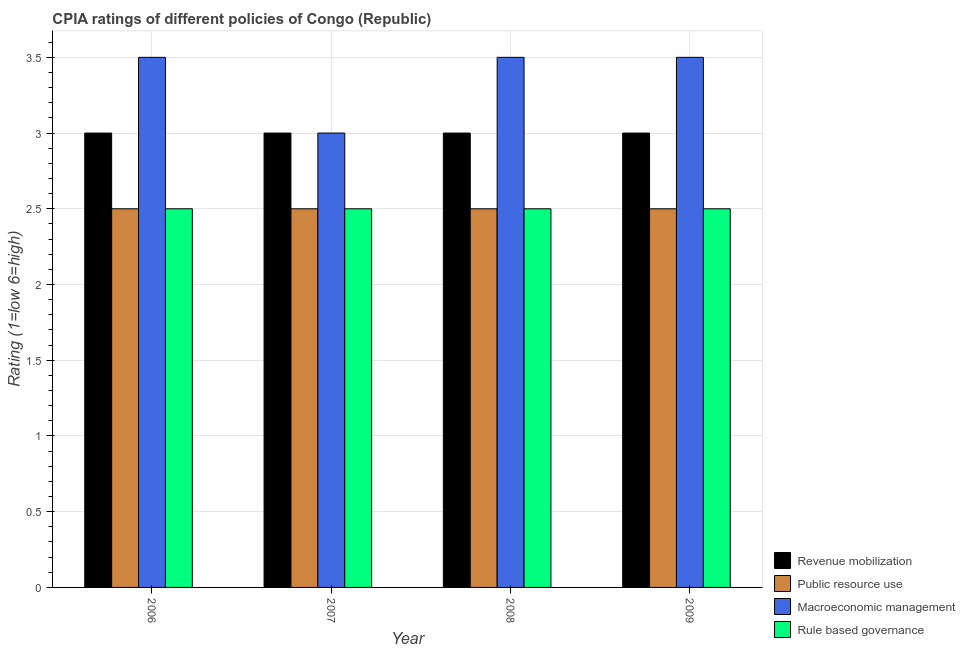How many groups of bars are there?
Provide a succinct answer. 4. Are the number of bars per tick equal to the number of legend labels?
Provide a succinct answer. Yes. Are the number of bars on each tick of the X-axis equal?
Keep it short and to the point. Yes. What is the label of the 3rd group of bars from the left?
Keep it short and to the point. 2008. What is the cpia rating of rule based governance in 2008?
Your response must be concise. 2.5. Across all years, what is the minimum cpia rating of rule based governance?
Your answer should be very brief. 2.5. In which year was the cpia rating of public resource use maximum?
Your answer should be very brief. 2006. What is the total cpia rating of public resource use in the graph?
Your answer should be very brief. 10. In the year 2009, what is the difference between the cpia rating of revenue mobilization and cpia rating of public resource use?
Keep it short and to the point. 0. Is the cpia rating of macroeconomic management in 2008 less than that in 2009?
Make the answer very short. No. What is the difference between the highest and the second highest cpia rating of revenue mobilization?
Ensure brevity in your answer.  0. In how many years, is the cpia rating of revenue mobilization greater than the average cpia rating of revenue mobilization taken over all years?
Ensure brevity in your answer.  0. Is the sum of the cpia rating of macroeconomic management in 2008 and 2009 greater than the maximum cpia rating of public resource use across all years?
Ensure brevity in your answer.  Yes. Is it the case that in every year, the sum of the cpia rating of rule based governance and cpia rating of revenue mobilization is greater than the sum of cpia rating of public resource use and cpia rating of macroeconomic management?
Offer a very short reply. No. What does the 2nd bar from the left in 2008 represents?
Your answer should be very brief. Public resource use. What does the 3rd bar from the right in 2006 represents?
Provide a short and direct response. Public resource use. Is it the case that in every year, the sum of the cpia rating of revenue mobilization and cpia rating of public resource use is greater than the cpia rating of macroeconomic management?
Give a very brief answer. Yes. How many years are there in the graph?
Provide a short and direct response. 4. Are the values on the major ticks of Y-axis written in scientific E-notation?
Your response must be concise. No. How are the legend labels stacked?
Your response must be concise. Vertical. What is the title of the graph?
Ensure brevity in your answer.  CPIA ratings of different policies of Congo (Republic). Does "First 20% of population" appear as one of the legend labels in the graph?
Give a very brief answer. No. What is the label or title of the Y-axis?
Make the answer very short. Rating (1=low 6=high). What is the Rating (1=low 6=high) in Revenue mobilization in 2006?
Give a very brief answer. 3. What is the Rating (1=low 6=high) in Public resource use in 2006?
Your answer should be compact. 2.5. What is the Rating (1=low 6=high) of Rule based governance in 2006?
Keep it short and to the point. 2.5. What is the Rating (1=low 6=high) of Revenue mobilization in 2007?
Ensure brevity in your answer.  3. What is the Rating (1=low 6=high) in Revenue mobilization in 2009?
Keep it short and to the point. 3. Across all years, what is the maximum Rating (1=low 6=high) in Revenue mobilization?
Your answer should be compact. 3. Across all years, what is the maximum Rating (1=low 6=high) in Public resource use?
Provide a succinct answer. 2.5. Across all years, what is the maximum Rating (1=low 6=high) of Macroeconomic management?
Your answer should be very brief. 3.5. Across all years, what is the maximum Rating (1=low 6=high) of Rule based governance?
Your response must be concise. 2.5. What is the total Rating (1=low 6=high) of Revenue mobilization in the graph?
Ensure brevity in your answer.  12. What is the total Rating (1=low 6=high) in Macroeconomic management in the graph?
Keep it short and to the point. 13.5. What is the difference between the Rating (1=low 6=high) in Revenue mobilization in 2006 and that in 2007?
Keep it short and to the point. 0. What is the difference between the Rating (1=low 6=high) in Public resource use in 2006 and that in 2007?
Keep it short and to the point. 0. What is the difference between the Rating (1=low 6=high) of Macroeconomic management in 2006 and that in 2007?
Give a very brief answer. 0.5. What is the difference between the Rating (1=low 6=high) in Revenue mobilization in 2006 and that in 2008?
Your answer should be very brief. 0. What is the difference between the Rating (1=low 6=high) of Public resource use in 2006 and that in 2008?
Give a very brief answer. 0. What is the difference between the Rating (1=low 6=high) of Macroeconomic management in 2006 and that in 2008?
Ensure brevity in your answer.  0. What is the difference between the Rating (1=low 6=high) in Public resource use in 2006 and that in 2009?
Your answer should be very brief. 0. What is the difference between the Rating (1=low 6=high) in Rule based governance in 2006 and that in 2009?
Keep it short and to the point. 0. What is the difference between the Rating (1=low 6=high) of Rule based governance in 2007 and that in 2008?
Give a very brief answer. 0. What is the difference between the Rating (1=low 6=high) of Revenue mobilization in 2007 and that in 2009?
Make the answer very short. 0. What is the difference between the Rating (1=low 6=high) in Public resource use in 2007 and that in 2009?
Provide a short and direct response. 0. What is the difference between the Rating (1=low 6=high) of Rule based governance in 2007 and that in 2009?
Make the answer very short. 0. What is the difference between the Rating (1=low 6=high) of Rule based governance in 2008 and that in 2009?
Your answer should be very brief. 0. What is the difference between the Rating (1=low 6=high) of Revenue mobilization in 2006 and the Rating (1=low 6=high) of Macroeconomic management in 2007?
Your answer should be compact. 0. What is the difference between the Rating (1=low 6=high) in Revenue mobilization in 2006 and the Rating (1=low 6=high) in Rule based governance in 2007?
Your answer should be compact. 0.5. What is the difference between the Rating (1=low 6=high) of Public resource use in 2006 and the Rating (1=low 6=high) of Macroeconomic management in 2007?
Your answer should be compact. -0.5. What is the difference between the Rating (1=low 6=high) in Revenue mobilization in 2006 and the Rating (1=low 6=high) in Public resource use in 2009?
Provide a succinct answer. 0.5. What is the difference between the Rating (1=low 6=high) of Revenue mobilization in 2006 and the Rating (1=low 6=high) of Macroeconomic management in 2009?
Provide a succinct answer. -0.5. What is the difference between the Rating (1=low 6=high) in Revenue mobilization in 2006 and the Rating (1=low 6=high) in Rule based governance in 2009?
Your response must be concise. 0.5. What is the difference between the Rating (1=low 6=high) in Macroeconomic management in 2006 and the Rating (1=low 6=high) in Rule based governance in 2009?
Offer a terse response. 1. What is the difference between the Rating (1=low 6=high) in Revenue mobilization in 2007 and the Rating (1=low 6=high) in Rule based governance in 2008?
Make the answer very short. 0.5. What is the difference between the Rating (1=low 6=high) in Public resource use in 2007 and the Rating (1=low 6=high) in Rule based governance in 2008?
Offer a very short reply. 0. What is the difference between the Rating (1=low 6=high) in Macroeconomic management in 2007 and the Rating (1=low 6=high) in Rule based governance in 2008?
Provide a succinct answer. 0.5. What is the difference between the Rating (1=low 6=high) in Revenue mobilization in 2007 and the Rating (1=low 6=high) in Public resource use in 2009?
Provide a succinct answer. 0.5. What is the difference between the Rating (1=low 6=high) in Revenue mobilization in 2007 and the Rating (1=low 6=high) in Rule based governance in 2009?
Ensure brevity in your answer.  0.5. What is the difference between the Rating (1=low 6=high) in Macroeconomic management in 2007 and the Rating (1=low 6=high) in Rule based governance in 2009?
Your response must be concise. 0.5. What is the difference between the Rating (1=low 6=high) of Revenue mobilization in 2008 and the Rating (1=low 6=high) of Public resource use in 2009?
Your response must be concise. 0.5. What is the difference between the Rating (1=low 6=high) in Revenue mobilization in 2008 and the Rating (1=low 6=high) in Macroeconomic management in 2009?
Keep it short and to the point. -0.5. What is the difference between the Rating (1=low 6=high) of Public resource use in 2008 and the Rating (1=low 6=high) of Macroeconomic management in 2009?
Offer a terse response. -1. What is the difference between the Rating (1=low 6=high) of Macroeconomic management in 2008 and the Rating (1=low 6=high) of Rule based governance in 2009?
Provide a succinct answer. 1. What is the average Rating (1=low 6=high) in Macroeconomic management per year?
Provide a short and direct response. 3.38. In the year 2006, what is the difference between the Rating (1=low 6=high) in Public resource use and Rating (1=low 6=high) in Macroeconomic management?
Make the answer very short. -1. In the year 2006, what is the difference between the Rating (1=low 6=high) of Public resource use and Rating (1=low 6=high) of Rule based governance?
Your answer should be compact. 0. In the year 2006, what is the difference between the Rating (1=low 6=high) of Macroeconomic management and Rating (1=low 6=high) of Rule based governance?
Provide a succinct answer. 1. In the year 2007, what is the difference between the Rating (1=low 6=high) of Revenue mobilization and Rating (1=low 6=high) of Macroeconomic management?
Provide a succinct answer. 0. In the year 2007, what is the difference between the Rating (1=low 6=high) in Revenue mobilization and Rating (1=low 6=high) in Rule based governance?
Provide a short and direct response. 0.5. In the year 2007, what is the difference between the Rating (1=low 6=high) in Public resource use and Rating (1=low 6=high) in Macroeconomic management?
Offer a very short reply. -0.5. In the year 2008, what is the difference between the Rating (1=low 6=high) of Public resource use and Rating (1=low 6=high) of Macroeconomic management?
Your answer should be very brief. -1. In the year 2008, what is the difference between the Rating (1=low 6=high) in Public resource use and Rating (1=low 6=high) in Rule based governance?
Provide a succinct answer. 0. In the year 2008, what is the difference between the Rating (1=low 6=high) in Macroeconomic management and Rating (1=low 6=high) in Rule based governance?
Provide a short and direct response. 1. In the year 2009, what is the difference between the Rating (1=low 6=high) of Revenue mobilization and Rating (1=low 6=high) of Public resource use?
Offer a terse response. 0.5. In the year 2009, what is the difference between the Rating (1=low 6=high) of Revenue mobilization and Rating (1=low 6=high) of Macroeconomic management?
Make the answer very short. -0.5. In the year 2009, what is the difference between the Rating (1=low 6=high) of Public resource use and Rating (1=low 6=high) of Rule based governance?
Make the answer very short. 0. In the year 2009, what is the difference between the Rating (1=low 6=high) of Macroeconomic management and Rating (1=low 6=high) of Rule based governance?
Provide a succinct answer. 1. What is the ratio of the Rating (1=low 6=high) in Revenue mobilization in 2006 to that in 2008?
Make the answer very short. 1. What is the ratio of the Rating (1=low 6=high) in Public resource use in 2006 to that in 2008?
Keep it short and to the point. 1. What is the ratio of the Rating (1=low 6=high) in Macroeconomic management in 2006 to that in 2008?
Your answer should be very brief. 1. What is the ratio of the Rating (1=low 6=high) of Rule based governance in 2006 to that in 2008?
Provide a succinct answer. 1. What is the ratio of the Rating (1=low 6=high) in Revenue mobilization in 2007 to that in 2008?
Your response must be concise. 1. What is the ratio of the Rating (1=low 6=high) of Macroeconomic management in 2007 to that in 2008?
Make the answer very short. 0.86. What is the ratio of the Rating (1=low 6=high) of Rule based governance in 2007 to that in 2008?
Offer a terse response. 1. What is the ratio of the Rating (1=low 6=high) of Revenue mobilization in 2007 to that in 2009?
Your answer should be very brief. 1. What is the difference between the highest and the second highest Rating (1=low 6=high) in Macroeconomic management?
Your answer should be very brief. 0. What is the difference between the highest and the lowest Rating (1=low 6=high) of Revenue mobilization?
Your response must be concise. 0. 